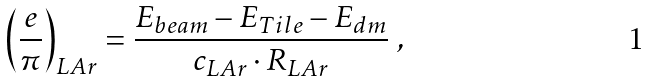Convert formula to latex. <formula><loc_0><loc_0><loc_500><loc_500>\left ( \frac { e } { \pi } \right ) _ { L A r } = \frac { E _ { b e a m } - E _ { T i l e } - E _ { d m } } { c _ { L A r } \cdot R _ { L A r } } \ ,</formula> 